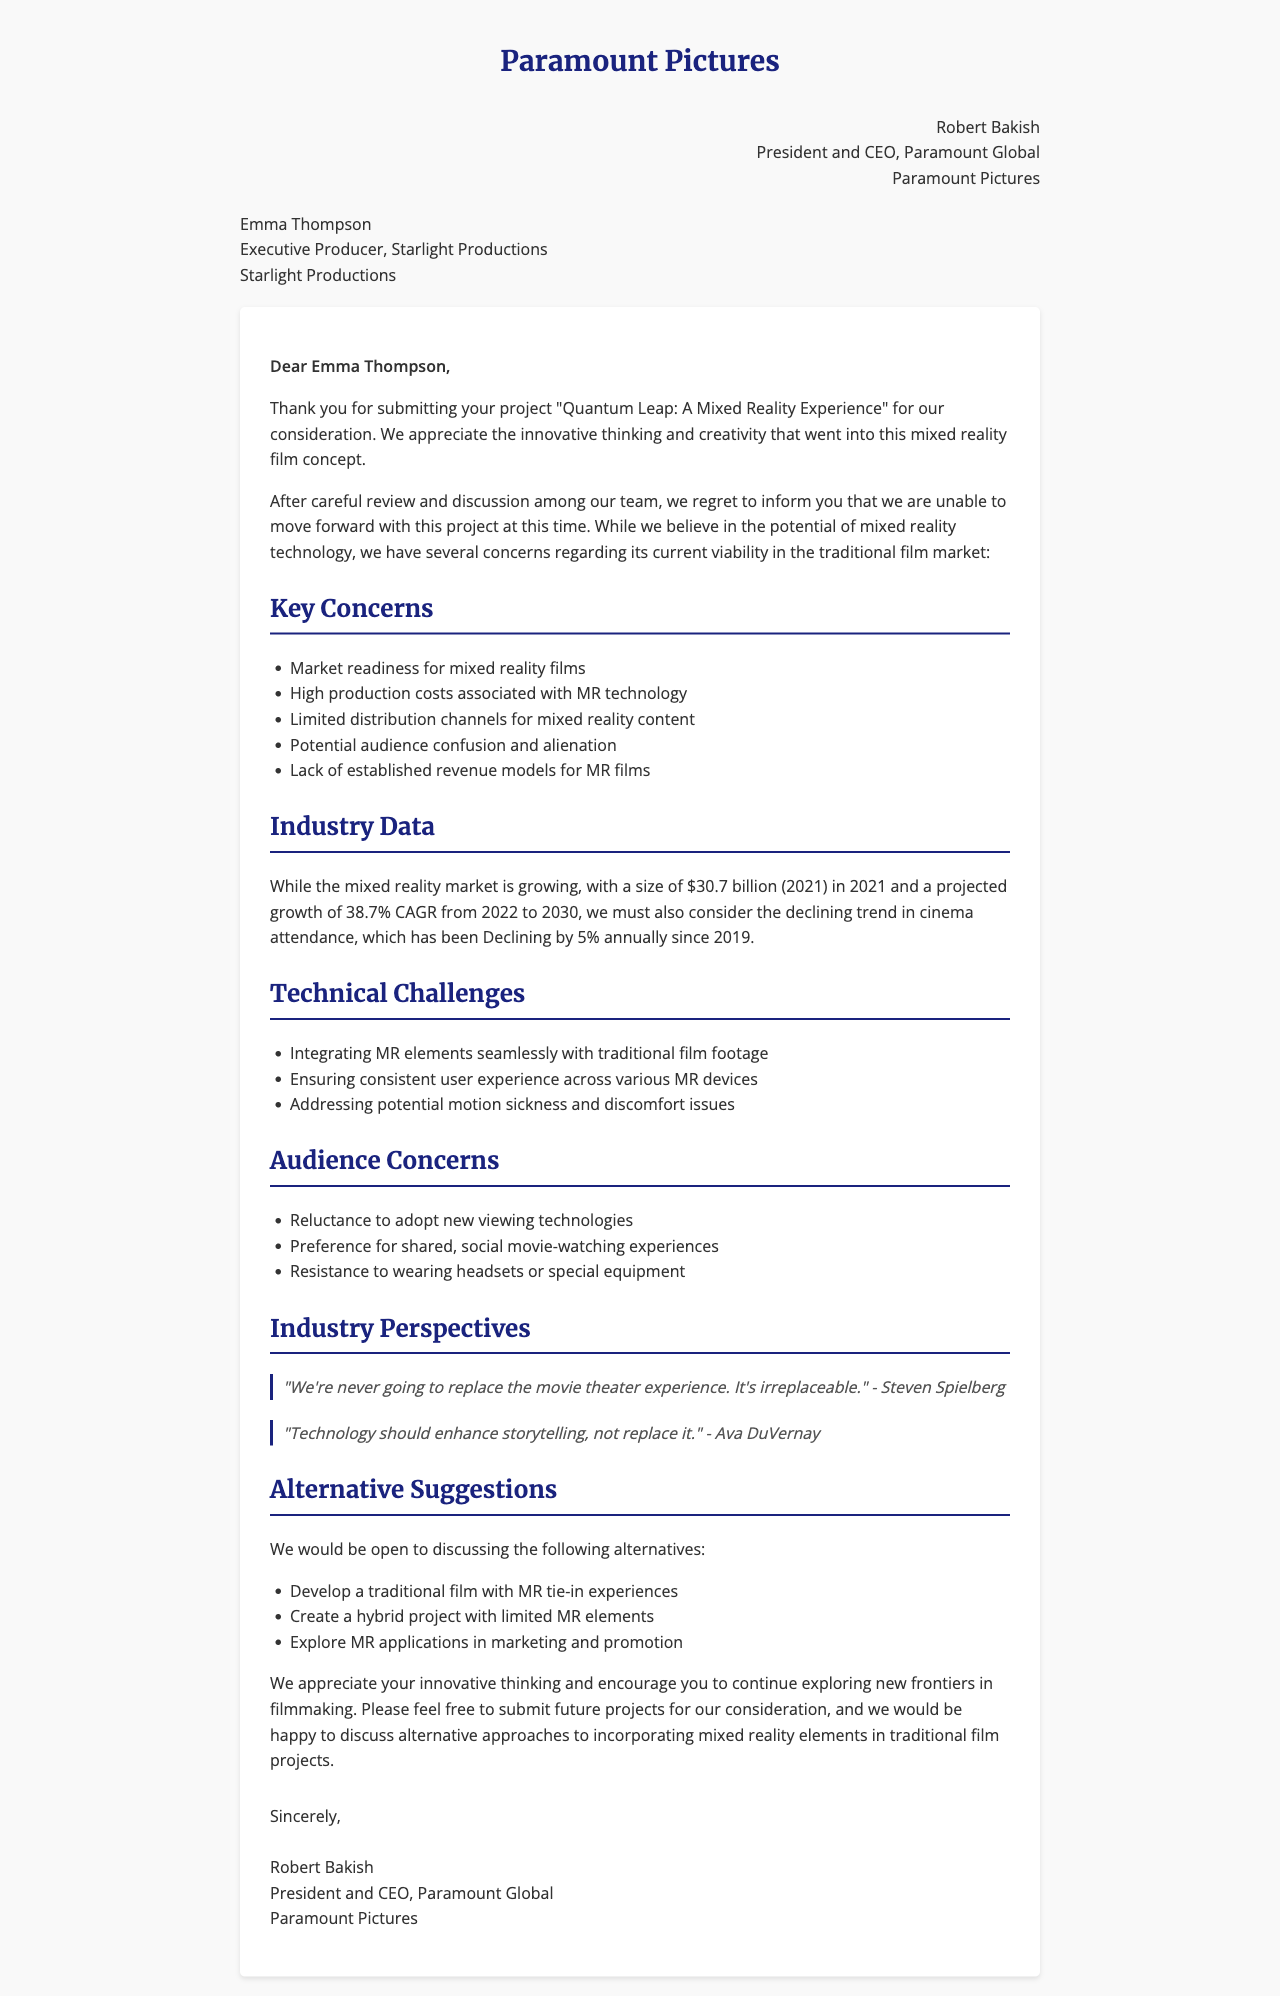What is the name of the project? The project name is mentioned in the document as "Quantum Leap: A Mixed Reality Experience."
Answer: Quantum Leap: A Mixed Reality Experience Who is the sender of the letter? The sender is identified as Robert Bakish, along with his title and affiliation.
Answer: Robert Bakish What is the main reason for the rejection? The letter outlines several concerns, but the main issue revolves around the current viability of mixed reality in traditional film markets.
Answer: Market readiness for mixed reality films What is the projected growth rate for the mixed reality market? The document specifies a compound annual growth rate (CAGR) projected for the market.
Answer: 38.7% CAGR from 2022 to 2030 What technology challenge is mentioned regarding user experience? A specific issue related to the user experience in mixed reality is highlighted in the challenges.
Answer: Ensuring consistent user experience across various MR devices What alternative suggestions are provided in the letter? The letter suggests alternatives to the original project to adapt to market conditions.
Answer: Develop a traditional film with MR tie-in experiences What quote is attributed to Steven Spielberg in the document? The document includes a perspective from Steven Spielberg regarding the cinema experience.
Answer: "We're never going to replace the movie theater experience. It's irreplaceable." What declining trend is noted in the industry data? The letter mentions a specific decline related to cinema attendance that impacts the market.
Answer: Declining by 5% annually since 2019 